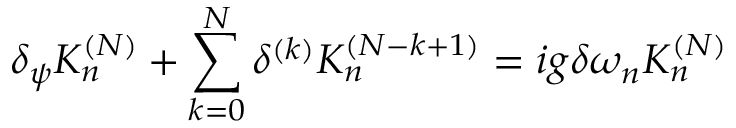<formula> <loc_0><loc_0><loc_500><loc_500>\delta _ { \psi } K _ { n } ^ { ( N ) } + \sum _ { k = 0 } ^ { N } \delta ^ { ( k ) } K _ { n } ^ { ( N - k + 1 ) } = i g \delta \omega _ { n } K _ { n } ^ { ( N ) }</formula> 